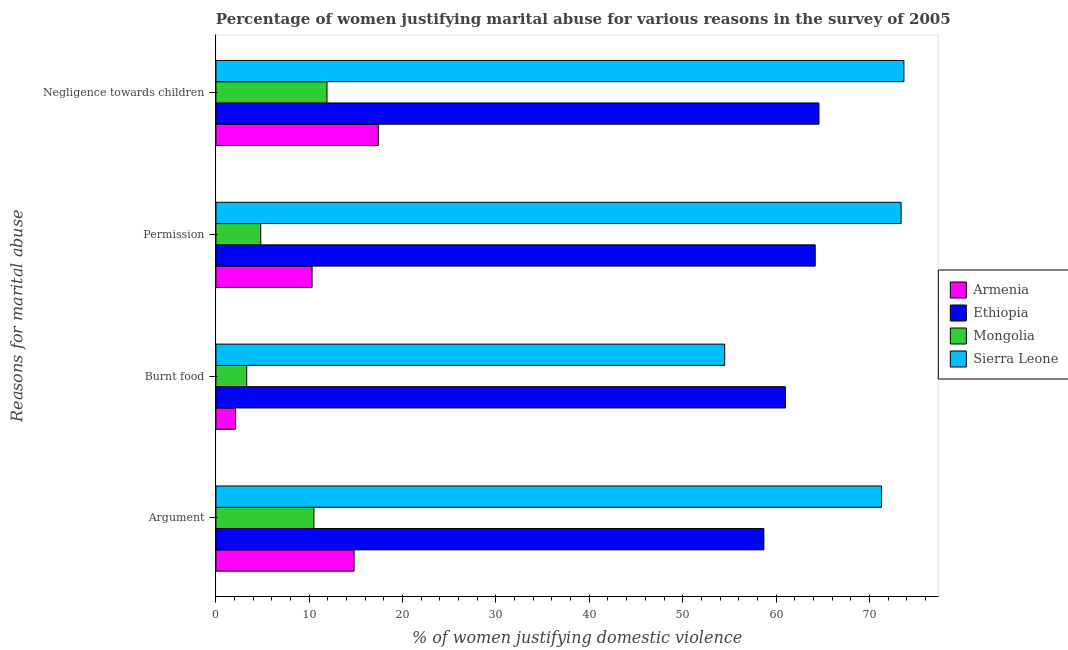How many groups of bars are there?
Offer a very short reply. 4. Are the number of bars per tick equal to the number of legend labels?
Make the answer very short. Yes. What is the label of the 3rd group of bars from the top?
Make the answer very short. Burnt food. What is the percentage of women justifying abuse for showing negligence towards children in Armenia?
Your answer should be very brief. 17.4. Across all countries, what is the maximum percentage of women justifying abuse for burning food?
Provide a succinct answer. 61. In which country was the percentage of women justifying abuse for burning food maximum?
Give a very brief answer. Ethiopia. In which country was the percentage of women justifying abuse for going without permission minimum?
Your answer should be very brief. Mongolia. What is the total percentage of women justifying abuse for showing negligence towards children in the graph?
Offer a very short reply. 167.6. What is the difference between the percentage of women justifying abuse in the case of an argument in Armenia and that in Mongolia?
Your answer should be very brief. 4.3. What is the difference between the percentage of women justifying abuse for showing negligence towards children in Sierra Leone and the percentage of women justifying abuse for burning food in Ethiopia?
Your answer should be compact. 12.7. What is the average percentage of women justifying abuse for showing negligence towards children per country?
Provide a succinct answer. 41.9. What is the difference between the percentage of women justifying abuse for going without permission and percentage of women justifying abuse in the case of an argument in Sierra Leone?
Make the answer very short. 2.1. What is the ratio of the percentage of women justifying abuse for showing negligence towards children in Armenia to that in Ethiopia?
Provide a short and direct response. 0.27. Is the percentage of women justifying abuse for burning food in Sierra Leone less than that in Mongolia?
Provide a succinct answer. No. Is the difference between the percentage of women justifying abuse for going without permission in Sierra Leone and Ethiopia greater than the difference between the percentage of women justifying abuse for showing negligence towards children in Sierra Leone and Ethiopia?
Ensure brevity in your answer.  Yes. What is the difference between the highest and the second highest percentage of women justifying abuse for showing negligence towards children?
Your answer should be very brief. 9.1. What is the difference between the highest and the lowest percentage of women justifying abuse for going without permission?
Ensure brevity in your answer.  68.6. Is the sum of the percentage of women justifying abuse in the case of an argument in Ethiopia and Sierra Leone greater than the maximum percentage of women justifying abuse for showing negligence towards children across all countries?
Your response must be concise. Yes. Is it the case that in every country, the sum of the percentage of women justifying abuse for going without permission and percentage of women justifying abuse in the case of an argument is greater than the sum of percentage of women justifying abuse for burning food and percentage of women justifying abuse for showing negligence towards children?
Make the answer very short. No. What does the 3rd bar from the top in Negligence towards children represents?
Your answer should be very brief. Ethiopia. What does the 1st bar from the bottom in Burnt food represents?
Your answer should be very brief. Armenia. How many bars are there?
Provide a succinct answer. 16. Are all the bars in the graph horizontal?
Your answer should be compact. Yes. Are the values on the major ticks of X-axis written in scientific E-notation?
Provide a short and direct response. No. Does the graph contain grids?
Provide a succinct answer. No. Where does the legend appear in the graph?
Keep it short and to the point. Center right. How many legend labels are there?
Provide a succinct answer. 4. How are the legend labels stacked?
Give a very brief answer. Vertical. What is the title of the graph?
Offer a very short reply. Percentage of women justifying marital abuse for various reasons in the survey of 2005. Does "Kiribati" appear as one of the legend labels in the graph?
Give a very brief answer. No. What is the label or title of the X-axis?
Give a very brief answer. % of women justifying domestic violence. What is the label or title of the Y-axis?
Your response must be concise. Reasons for marital abuse. What is the % of women justifying domestic violence of Armenia in Argument?
Provide a short and direct response. 14.8. What is the % of women justifying domestic violence of Ethiopia in Argument?
Your answer should be compact. 58.7. What is the % of women justifying domestic violence of Mongolia in Argument?
Ensure brevity in your answer.  10.5. What is the % of women justifying domestic violence in Sierra Leone in Argument?
Ensure brevity in your answer.  71.3. What is the % of women justifying domestic violence in Mongolia in Burnt food?
Provide a short and direct response. 3.3. What is the % of women justifying domestic violence of Sierra Leone in Burnt food?
Provide a succinct answer. 54.5. What is the % of women justifying domestic violence in Armenia in Permission?
Offer a very short reply. 10.3. What is the % of women justifying domestic violence in Ethiopia in Permission?
Your answer should be compact. 64.2. What is the % of women justifying domestic violence in Mongolia in Permission?
Ensure brevity in your answer.  4.8. What is the % of women justifying domestic violence of Sierra Leone in Permission?
Keep it short and to the point. 73.4. What is the % of women justifying domestic violence of Armenia in Negligence towards children?
Offer a terse response. 17.4. What is the % of women justifying domestic violence of Ethiopia in Negligence towards children?
Offer a very short reply. 64.6. What is the % of women justifying domestic violence in Sierra Leone in Negligence towards children?
Your answer should be compact. 73.7. Across all Reasons for marital abuse, what is the maximum % of women justifying domestic violence of Ethiopia?
Keep it short and to the point. 64.6. Across all Reasons for marital abuse, what is the maximum % of women justifying domestic violence of Sierra Leone?
Provide a short and direct response. 73.7. Across all Reasons for marital abuse, what is the minimum % of women justifying domestic violence of Armenia?
Offer a terse response. 2.1. Across all Reasons for marital abuse, what is the minimum % of women justifying domestic violence of Ethiopia?
Provide a succinct answer. 58.7. Across all Reasons for marital abuse, what is the minimum % of women justifying domestic violence of Mongolia?
Your answer should be compact. 3.3. Across all Reasons for marital abuse, what is the minimum % of women justifying domestic violence of Sierra Leone?
Your answer should be very brief. 54.5. What is the total % of women justifying domestic violence of Armenia in the graph?
Keep it short and to the point. 44.6. What is the total % of women justifying domestic violence of Ethiopia in the graph?
Offer a terse response. 248.5. What is the total % of women justifying domestic violence of Mongolia in the graph?
Your answer should be compact. 30.5. What is the total % of women justifying domestic violence in Sierra Leone in the graph?
Provide a succinct answer. 272.9. What is the difference between the % of women justifying domestic violence of Armenia in Argument and that in Burnt food?
Your answer should be compact. 12.7. What is the difference between the % of women justifying domestic violence of Ethiopia in Argument and that in Burnt food?
Your answer should be very brief. -2.3. What is the difference between the % of women justifying domestic violence in Mongolia in Argument and that in Burnt food?
Ensure brevity in your answer.  7.2. What is the difference between the % of women justifying domestic violence in Armenia in Argument and that in Permission?
Offer a terse response. 4.5. What is the difference between the % of women justifying domestic violence in Mongolia in Argument and that in Permission?
Keep it short and to the point. 5.7. What is the difference between the % of women justifying domestic violence in Sierra Leone in Argument and that in Permission?
Offer a terse response. -2.1. What is the difference between the % of women justifying domestic violence of Armenia in Argument and that in Negligence towards children?
Your response must be concise. -2.6. What is the difference between the % of women justifying domestic violence in Ethiopia in Argument and that in Negligence towards children?
Provide a succinct answer. -5.9. What is the difference between the % of women justifying domestic violence of Sierra Leone in Argument and that in Negligence towards children?
Your response must be concise. -2.4. What is the difference between the % of women justifying domestic violence of Mongolia in Burnt food and that in Permission?
Offer a very short reply. -1.5. What is the difference between the % of women justifying domestic violence in Sierra Leone in Burnt food and that in Permission?
Offer a very short reply. -18.9. What is the difference between the % of women justifying domestic violence of Armenia in Burnt food and that in Negligence towards children?
Give a very brief answer. -15.3. What is the difference between the % of women justifying domestic violence in Ethiopia in Burnt food and that in Negligence towards children?
Give a very brief answer. -3.6. What is the difference between the % of women justifying domestic violence of Sierra Leone in Burnt food and that in Negligence towards children?
Your answer should be compact. -19.2. What is the difference between the % of women justifying domestic violence in Armenia in Permission and that in Negligence towards children?
Offer a very short reply. -7.1. What is the difference between the % of women justifying domestic violence in Mongolia in Permission and that in Negligence towards children?
Make the answer very short. -7.1. What is the difference between the % of women justifying domestic violence in Armenia in Argument and the % of women justifying domestic violence in Ethiopia in Burnt food?
Your answer should be very brief. -46.2. What is the difference between the % of women justifying domestic violence in Armenia in Argument and the % of women justifying domestic violence in Mongolia in Burnt food?
Your answer should be compact. 11.5. What is the difference between the % of women justifying domestic violence of Armenia in Argument and the % of women justifying domestic violence of Sierra Leone in Burnt food?
Your response must be concise. -39.7. What is the difference between the % of women justifying domestic violence in Ethiopia in Argument and the % of women justifying domestic violence in Mongolia in Burnt food?
Make the answer very short. 55.4. What is the difference between the % of women justifying domestic violence in Mongolia in Argument and the % of women justifying domestic violence in Sierra Leone in Burnt food?
Your response must be concise. -44. What is the difference between the % of women justifying domestic violence in Armenia in Argument and the % of women justifying domestic violence in Ethiopia in Permission?
Keep it short and to the point. -49.4. What is the difference between the % of women justifying domestic violence of Armenia in Argument and the % of women justifying domestic violence of Mongolia in Permission?
Ensure brevity in your answer.  10. What is the difference between the % of women justifying domestic violence in Armenia in Argument and the % of women justifying domestic violence in Sierra Leone in Permission?
Give a very brief answer. -58.6. What is the difference between the % of women justifying domestic violence in Ethiopia in Argument and the % of women justifying domestic violence in Mongolia in Permission?
Provide a succinct answer. 53.9. What is the difference between the % of women justifying domestic violence of Ethiopia in Argument and the % of women justifying domestic violence of Sierra Leone in Permission?
Your answer should be very brief. -14.7. What is the difference between the % of women justifying domestic violence of Mongolia in Argument and the % of women justifying domestic violence of Sierra Leone in Permission?
Your answer should be very brief. -62.9. What is the difference between the % of women justifying domestic violence in Armenia in Argument and the % of women justifying domestic violence in Ethiopia in Negligence towards children?
Provide a short and direct response. -49.8. What is the difference between the % of women justifying domestic violence in Armenia in Argument and the % of women justifying domestic violence in Sierra Leone in Negligence towards children?
Keep it short and to the point. -58.9. What is the difference between the % of women justifying domestic violence of Ethiopia in Argument and the % of women justifying domestic violence of Mongolia in Negligence towards children?
Your response must be concise. 46.8. What is the difference between the % of women justifying domestic violence of Ethiopia in Argument and the % of women justifying domestic violence of Sierra Leone in Negligence towards children?
Ensure brevity in your answer.  -15. What is the difference between the % of women justifying domestic violence in Mongolia in Argument and the % of women justifying domestic violence in Sierra Leone in Negligence towards children?
Provide a succinct answer. -63.2. What is the difference between the % of women justifying domestic violence of Armenia in Burnt food and the % of women justifying domestic violence of Ethiopia in Permission?
Provide a short and direct response. -62.1. What is the difference between the % of women justifying domestic violence of Armenia in Burnt food and the % of women justifying domestic violence of Sierra Leone in Permission?
Offer a very short reply. -71.3. What is the difference between the % of women justifying domestic violence in Ethiopia in Burnt food and the % of women justifying domestic violence in Mongolia in Permission?
Keep it short and to the point. 56.2. What is the difference between the % of women justifying domestic violence of Mongolia in Burnt food and the % of women justifying domestic violence of Sierra Leone in Permission?
Your response must be concise. -70.1. What is the difference between the % of women justifying domestic violence of Armenia in Burnt food and the % of women justifying domestic violence of Ethiopia in Negligence towards children?
Ensure brevity in your answer.  -62.5. What is the difference between the % of women justifying domestic violence of Armenia in Burnt food and the % of women justifying domestic violence of Mongolia in Negligence towards children?
Your response must be concise. -9.8. What is the difference between the % of women justifying domestic violence of Armenia in Burnt food and the % of women justifying domestic violence of Sierra Leone in Negligence towards children?
Provide a short and direct response. -71.6. What is the difference between the % of women justifying domestic violence in Ethiopia in Burnt food and the % of women justifying domestic violence in Mongolia in Negligence towards children?
Your answer should be very brief. 49.1. What is the difference between the % of women justifying domestic violence of Mongolia in Burnt food and the % of women justifying domestic violence of Sierra Leone in Negligence towards children?
Keep it short and to the point. -70.4. What is the difference between the % of women justifying domestic violence in Armenia in Permission and the % of women justifying domestic violence in Ethiopia in Negligence towards children?
Your answer should be compact. -54.3. What is the difference between the % of women justifying domestic violence of Armenia in Permission and the % of women justifying domestic violence of Sierra Leone in Negligence towards children?
Provide a short and direct response. -63.4. What is the difference between the % of women justifying domestic violence of Ethiopia in Permission and the % of women justifying domestic violence of Mongolia in Negligence towards children?
Offer a very short reply. 52.3. What is the difference between the % of women justifying domestic violence in Ethiopia in Permission and the % of women justifying domestic violence in Sierra Leone in Negligence towards children?
Ensure brevity in your answer.  -9.5. What is the difference between the % of women justifying domestic violence of Mongolia in Permission and the % of women justifying domestic violence of Sierra Leone in Negligence towards children?
Provide a succinct answer. -68.9. What is the average % of women justifying domestic violence in Armenia per Reasons for marital abuse?
Offer a very short reply. 11.15. What is the average % of women justifying domestic violence in Ethiopia per Reasons for marital abuse?
Offer a terse response. 62.12. What is the average % of women justifying domestic violence of Mongolia per Reasons for marital abuse?
Give a very brief answer. 7.62. What is the average % of women justifying domestic violence of Sierra Leone per Reasons for marital abuse?
Offer a terse response. 68.22. What is the difference between the % of women justifying domestic violence in Armenia and % of women justifying domestic violence in Ethiopia in Argument?
Make the answer very short. -43.9. What is the difference between the % of women justifying domestic violence of Armenia and % of women justifying domestic violence of Sierra Leone in Argument?
Provide a succinct answer. -56.5. What is the difference between the % of women justifying domestic violence in Ethiopia and % of women justifying domestic violence in Mongolia in Argument?
Offer a very short reply. 48.2. What is the difference between the % of women justifying domestic violence of Ethiopia and % of women justifying domestic violence of Sierra Leone in Argument?
Offer a very short reply. -12.6. What is the difference between the % of women justifying domestic violence of Mongolia and % of women justifying domestic violence of Sierra Leone in Argument?
Offer a very short reply. -60.8. What is the difference between the % of women justifying domestic violence in Armenia and % of women justifying domestic violence in Ethiopia in Burnt food?
Provide a succinct answer. -58.9. What is the difference between the % of women justifying domestic violence in Armenia and % of women justifying domestic violence in Sierra Leone in Burnt food?
Provide a short and direct response. -52.4. What is the difference between the % of women justifying domestic violence of Ethiopia and % of women justifying domestic violence of Mongolia in Burnt food?
Provide a short and direct response. 57.7. What is the difference between the % of women justifying domestic violence of Mongolia and % of women justifying domestic violence of Sierra Leone in Burnt food?
Your answer should be very brief. -51.2. What is the difference between the % of women justifying domestic violence of Armenia and % of women justifying domestic violence of Ethiopia in Permission?
Provide a succinct answer. -53.9. What is the difference between the % of women justifying domestic violence of Armenia and % of women justifying domestic violence of Sierra Leone in Permission?
Provide a succinct answer. -63.1. What is the difference between the % of women justifying domestic violence of Ethiopia and % of women justifying domestic violence of Mongolia in Permission?
Make the answer very short. 59.4. What is the difference between the % of women justifying domestic violence of Ethiopia and % of women justifying domestic violence of Sierra Leone in Permission?
Offer a terse response. -9.2. What is the difference between the % of women justifying domestic violence in Mongolia and % of women justifying domestic violence in Sierra Leone in Permission?
Offer a very short reply. -68.6. What is the difference between the % of women justifying domestic violence in Armenia and % of women justifying domestic violence in Ethiopia in Negligence towards children?
Your answer should be compact. -47.2. What is the difference between the % of women justifying domestic violence in Armenia and % of women justifying domestic violence in Sierra Leone in Negligence towards children?
Your response must be concise. -56.3. What is the difference between the % of women justifying domestic violence in Ethiopia and % of women justifying domestic violence in Mongolia in Negligence towards children?
Provide a short and direct response. 52.7. What is the difference between the % of women justifying domestic violence in Ethiopia and % of women justifying domestic violence in Sierra Leone in Negligence towards children?
Offer a very short reply. -9.1. What is the difference between the % of women justifying domestic violence of Mongolia and % of women justifying domestic violence of Sierra Leone in Negligence towards children?
Ensure brevity in your answer.  -61.8. What is the ratio of the % of women justifying domestic violence of Armenia in Argument to that in Burnt food?
Give a very brief answer. 7.05. What is the ratio of the % of women justifying domestic violence of Ethiopia in Argument to that in Burnt food?
Your response must be concise. 0.96. What is the ratio of the % of women justifying domestic violence in Mongolia in Argument to that in Burnt food?
Keep it short and to the point. 3.18. What is the ratio of the % of women justifying domestic violence of Sierra Leone in Argument to that in Burnt food?
Your answer should be compact. 1.31. What is the ratio of the % of women justifying domestic violence in Armenia in Argument to that in Permission?
Provide a succinct answer. 1.44. What is the ratio of the % of women justifying domestic violence of Ethiopia in Argument to that in Permission?
Give a very brief answer. 0.91. What is the ratio of the % of women justifying domestic violence of Mongolia in Argument to that in Permission?
Your answer should be very brief. 2.19. What is the ratio of the % of women justifying domestic violence of Sierra Leone in Argument to that in Permission?
Provide a short and direct response. 0.97. What is the ratio of the % of women justifying domestic violence of Armenia in Argument to that in Negligence towards children?
Offer a terse response. 0.85. What is the ratio of the % of women justifying domestic violence of Ethiopia in Argument to that in Negligence towards children?
Provide a short and direct response. 0.91. What is the ratio of the % of women justifying domestic violence of Mongolia in Argument to that in Negligence towards children?
Offer a terse response. 0.88. What is the ratio of the % of women justifying domestic violence in Sierra Leone in Argument to that in Negligence towards children?
Give a very brief answer. 0.97. What is the ratio of the % of women justifying domestic violence in Armenia in Burnt food to that in Permission?
Keep it short and to the point. 0.2. What is the ratio of the % of women justifying domestic violence in Ethiopia in Burnt food to that in Permission?
Your answer should be very brief. 0.95. What is the ratio of the % of women justifying domestic violence of Mongolia in Burnt food to that in Permission?
Keep it short and to the point. 0.69. What is the ratio of the % of women justifying domestic violence in Sierra Leone in Burnt food to that in Permission?
Make the answer very short. 0.74. What is the ratio of the % of women justifying domestic violence in Armenia in Burnt food to that in Negligence towards children?
Your answer should be compact. 0.12. What is the ratio of the % of women justifying domestic violence of Ethiopia in Burnt food to that in Negligence towards children?
Give a very brief answer. 0.94. What is the ratio of the % of women justifying domestic violence of Mongolia in Burnt food to that in Negligence towards children?
Ensure brevity in your answer.  0.28. What is the ratio of the % of women justifying domestic violence in Sierra Leone in Burnt food to that in Negligence towards children?
Ensure brevity in your answer.  0.74. What is the ratio of the % of women justifying domestic violence in Armenia in Permission to that in Negligence towards children?
Offer a very short reply. 0.59. What is the ratio of the % of women justifying domestic violence in Ethiopia in Permission to that in Negligence towards children?
Provide a short and direct response. 0.99. What is the ratio of the % of women justifying domestic violence in Mongolia in Permission to that in Negligence towards children?
Provide a succinct answer. 0.4. What is the ratio of the % of women justifying domestic violence of Sierra Leone in Permission to that in Negligence towards children?
Your answer should be very brief. 1. What is the difference between the highest and the second highest % of women justifying domestic violence of Armenia?
Give a very brief answer. 2.6. What is the difference between the highest and the second highest % of women justifying domestic violence of Ethiopia?
Offer a very short reply. 0.4. What is the difference between the highest and the second highest % of women justifying domestic violence of Mongolia?
Your answer should be very brief. 1.4. What is the difference between the highest and the second highest % of women justifying domestic violence in Sierra Leone?
Offer a very short reply. 0.3. What is the difference between the highest and the lowest % of women justifying domestic violence of Mongolia?
Your answer should be compact. 8.6. 